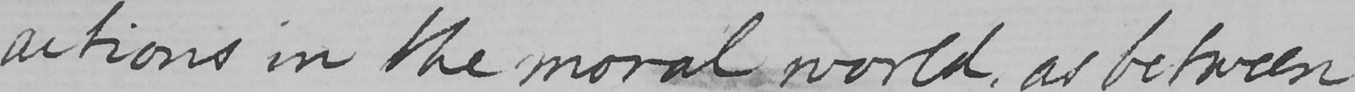Please provide the text content of this handwritten line. actions in the moral world , as between 